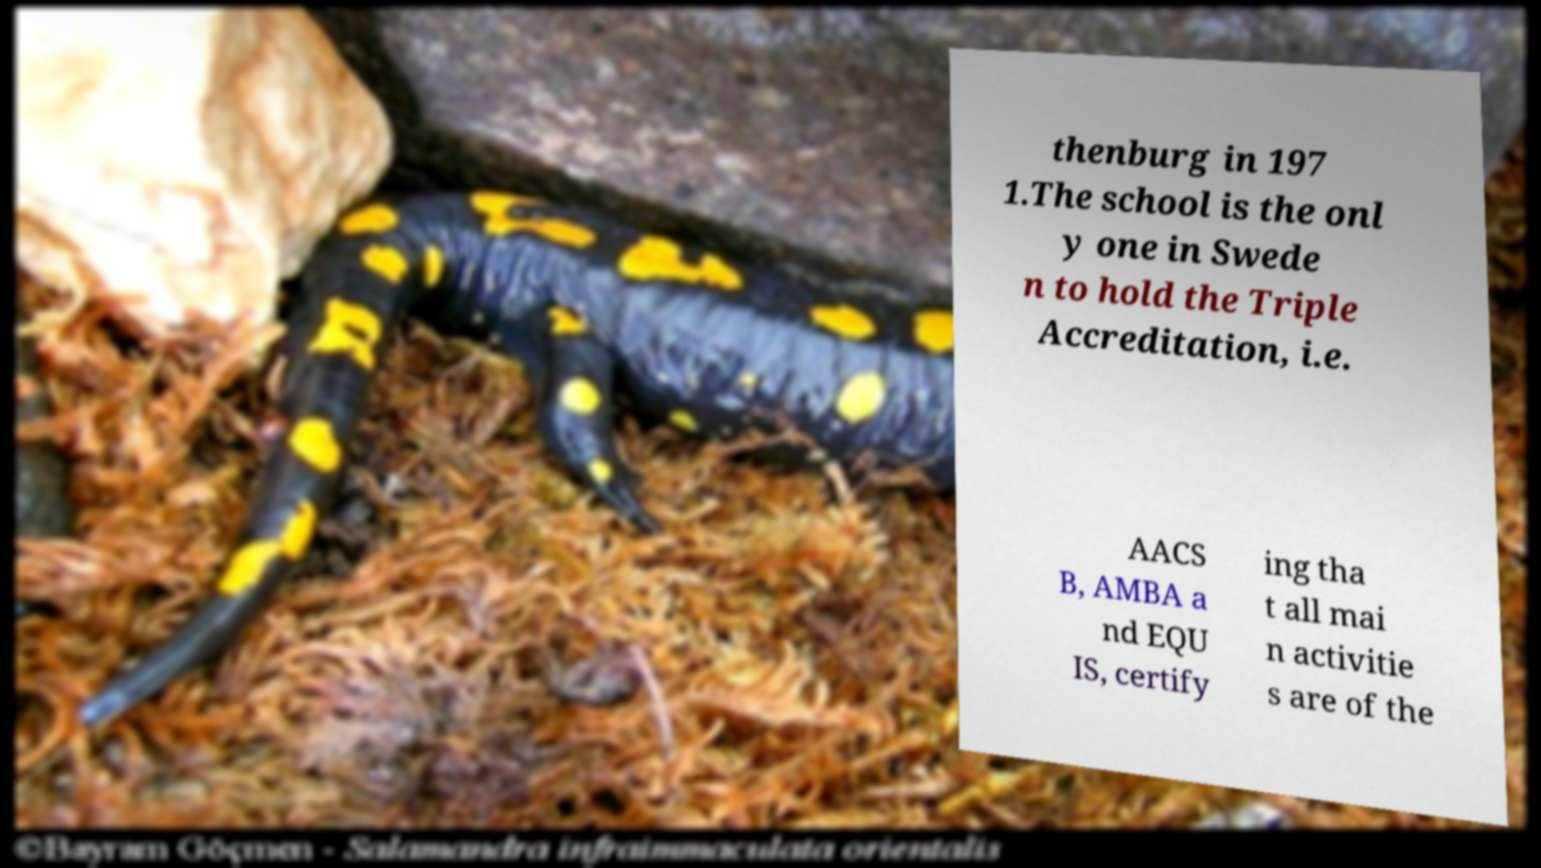For documentation purposes, I need the text within this image transcribed. Could you provide that? thenburg in 197 1.The school is the onl y one in Swede n to hold the Triple Accreditation, i.e. AACS B, AMBA a nd EQU IS, certify ing tha t all mai n activitie s are of the 